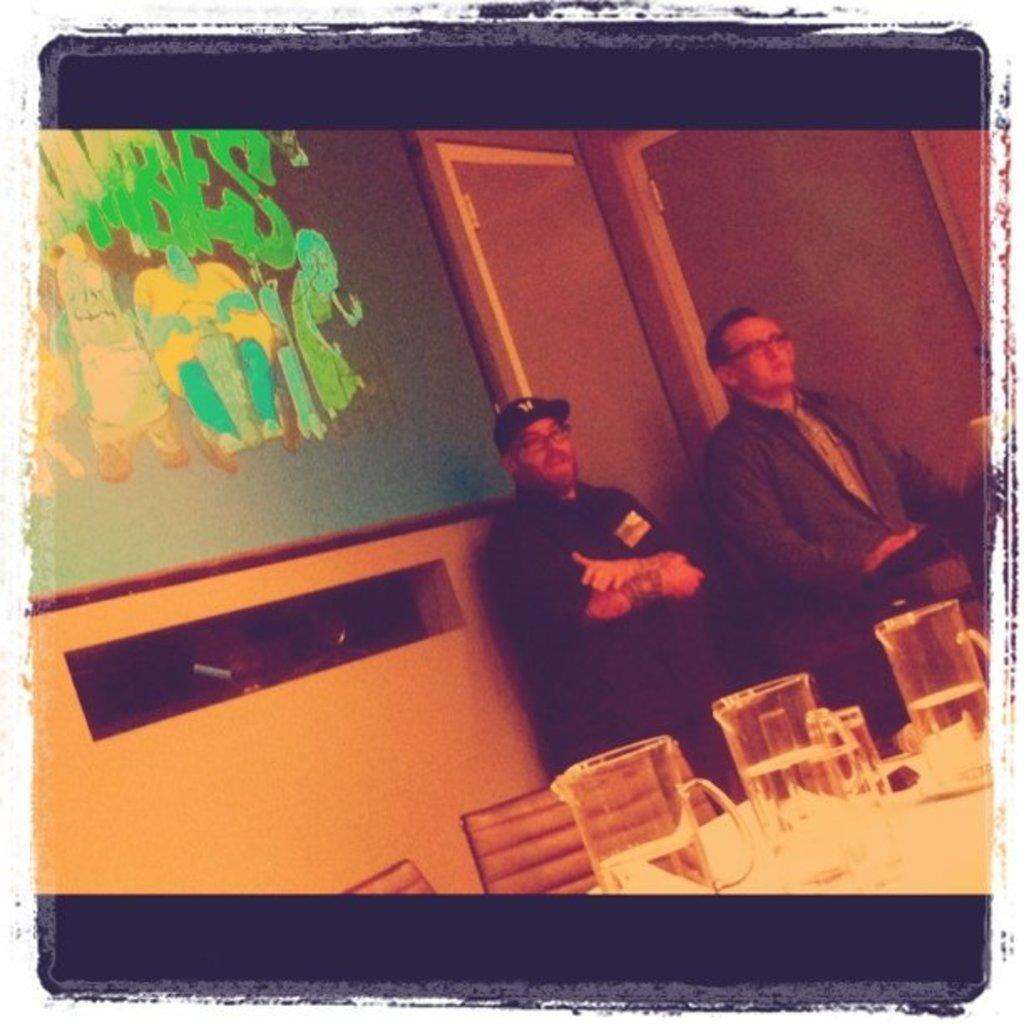What objects are on the table in the image? There are water jugs on a table in the image. Who or what can be seen on the right side of the image? Two men are standing on the right side of the image. What is located on the left side of the image? There is a projector screen on the left side of the image. What type of ground can be seen beneath the water jugs in the image? There is no ground visible beneath the water jugs in the image, as it appears to be an indoor setting. What experience do the two men have in the image? There is no information provided about the experience or background of the two men in the image. 